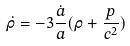Convert formula to latex. <formula><loc_0><loc_0><loc_500><loc_500>\dot { \rho } = - 3 \frac { \dot { a } } { a } ( \rho + \frac { p } { c ^ { 2 } } )</formula> 